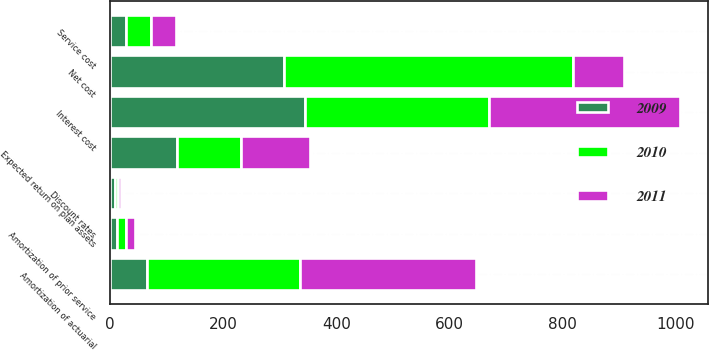Convert chart to OTSL. <chart><loc_0><loc_0><loc_500><loc_500><stacked_bar_chart><ecel><fcel>Service cost<fcel>Interest cost<fcel>Expected return on plan assets<fcel>Amortization of actuarial<fcel>Amortization of prior service<fcel>Net cost<fcel>Discount rates<nl><fcel>2010<fcel>44<fcel>326<fcel>113<fcel>271<fcel>16<fcel>512<fcel>5.2<nl><fcel>2011<fcel>44<fcel>337<fcel>122<fcel>311<fcel>16<fcel>89<fcel>5.6<nl><fcel>2009<fcel>28<fcel>344<fcel>118<fcel>65<fcel>12<fcel>307<fcel>8.2<nl></chart> 